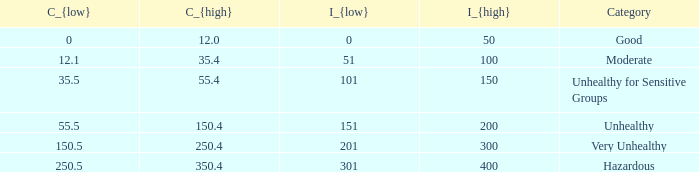What's the c_{high} when the c_{low} value is equal to 25 350.4. 